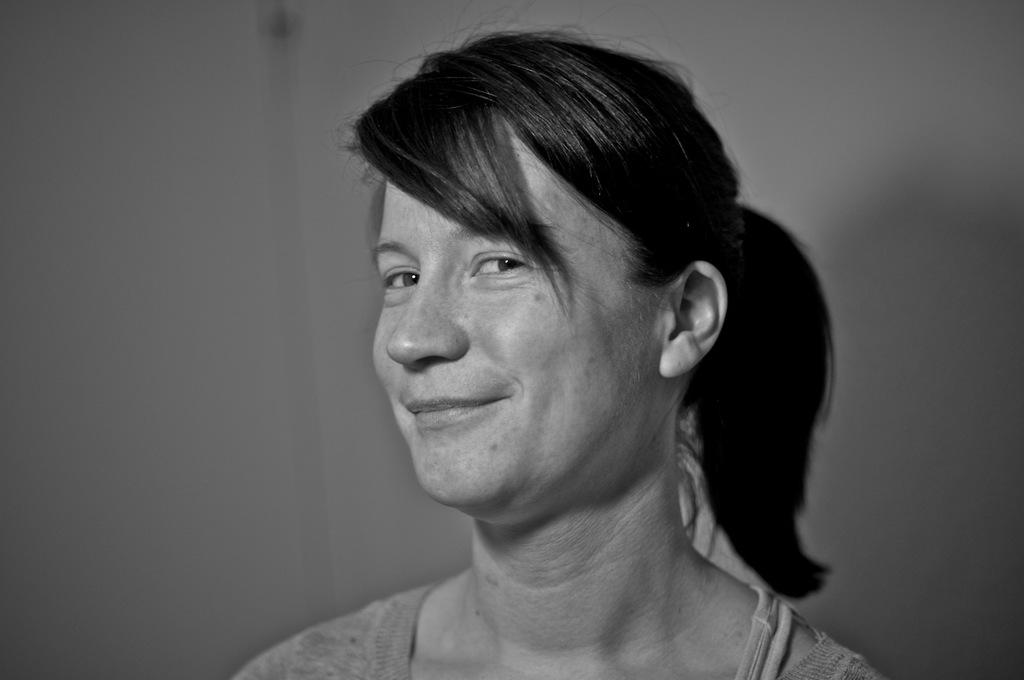Who is the main subject in the image? There is a lady in the image. What can be seen behind the lady? There is a wall visible behind the lady. How is the image presented in terms of color? The image is in black and white mode. What type of umbrella is the lady holding in the image? There is no umbrella present in the image. What shape is the curtain hanging from the wall in the image? There is no curtain present in the image. 